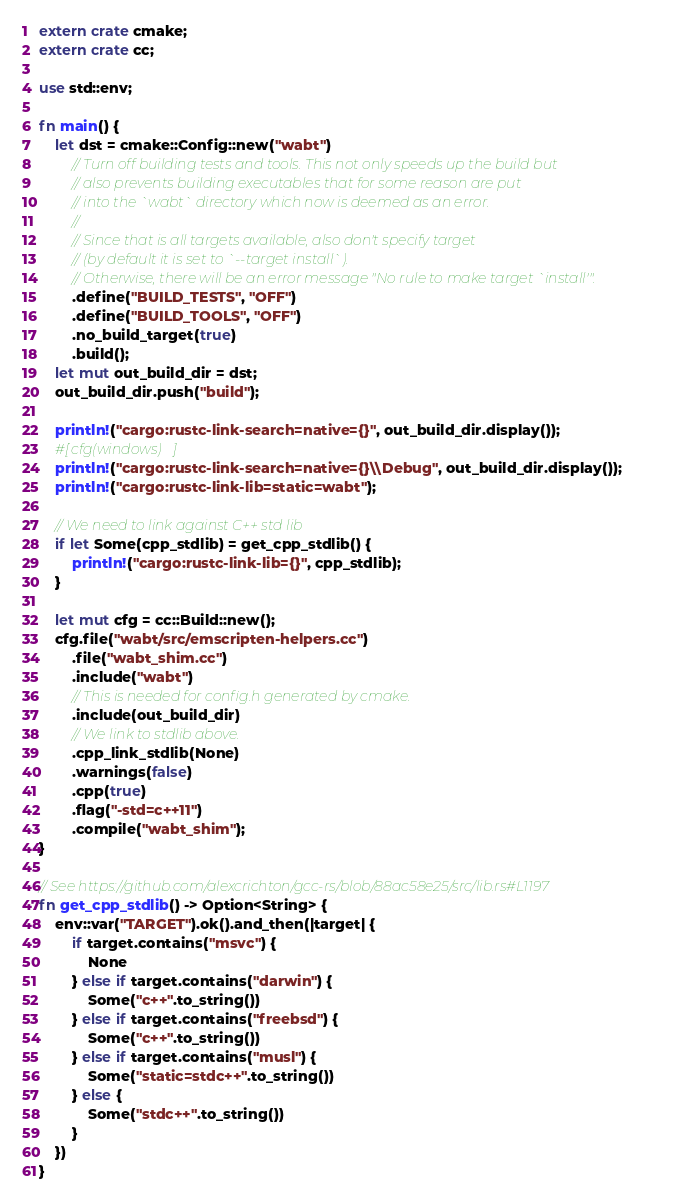<code> <loc_0><loc_0><loc_500><loc_500><_Rust_>extern crate cmake;
extern crate cc;

use std::env;

fn main() {
    let dst = cmake::Config::new("wabt")
        // Turn off building tests and tools. This not only speeds up the build but
        // also prevents building executables that for some reason are put 
        // into the `wabt` directory which now is deemed as an error.
        //
        // Since that is all targets available, also don't specify target 
        // (by default it is set to `--target install`).
        // Otherwise, there will be an error message "No rule to make target `install'".
        .define("BUILD_TESTS", "OFF")
        .define("BUILD_TOOLS", "OFF")
        .no_build_target(true)
        .build();
    let mut out_build_dir = dst;
    out_build_dir.push("build");

    println!("cargo:rustc-link-search=native={}", out_build_dir.display());
    #[cfg(windows)]
    println!("cargo:rustc-link-search=native={}\\Debug", out_build_dir.display());    
    println!("cargo:rustc-link-lib=static=wabt");
    
    // We need to link against C++ std lib
    if let Some(cpp_stdlib) = get_cpp_stdlib() {
        println!("cargo:rustc-link-lib={}", cpp_stdlib);
    }

    let mut cfg = cc::Build::new();
    cfg.file("wabt/src/emscripten-helpers.cc")
        .file("wabt_shim.cc")
        .include("wabt")
        // This is needed for config.h generated by cmake.
        .include(out_build_dir)
        // We link to stdlib above.
        .cpp_link_stdlib(None)
        .warnings(false)
        .cpp(true)
        .flag("-std=c++11")
        .compile("wabt_shim");
}

// See https://github.com/alexcrichton/gcc-rs/blob/88ac58e25/src/lib.rs#L1197
fn get_cpp_stdlib() -> Option<String> {
    env::var("TARGET").ok().and_then(|target| {
        if target.contains("msvc") {
            None
        } else if target.contains("darwin") {
            Some("c++".to_string())
        } else if target.contains("freebsd") {
            Some("c++".to_string())
        } else if target.contains("musl") {
            Some("static=stdc++".to_string())
        } else {
            Some("stdc++".to_string())
        }
    })
}
</code> 